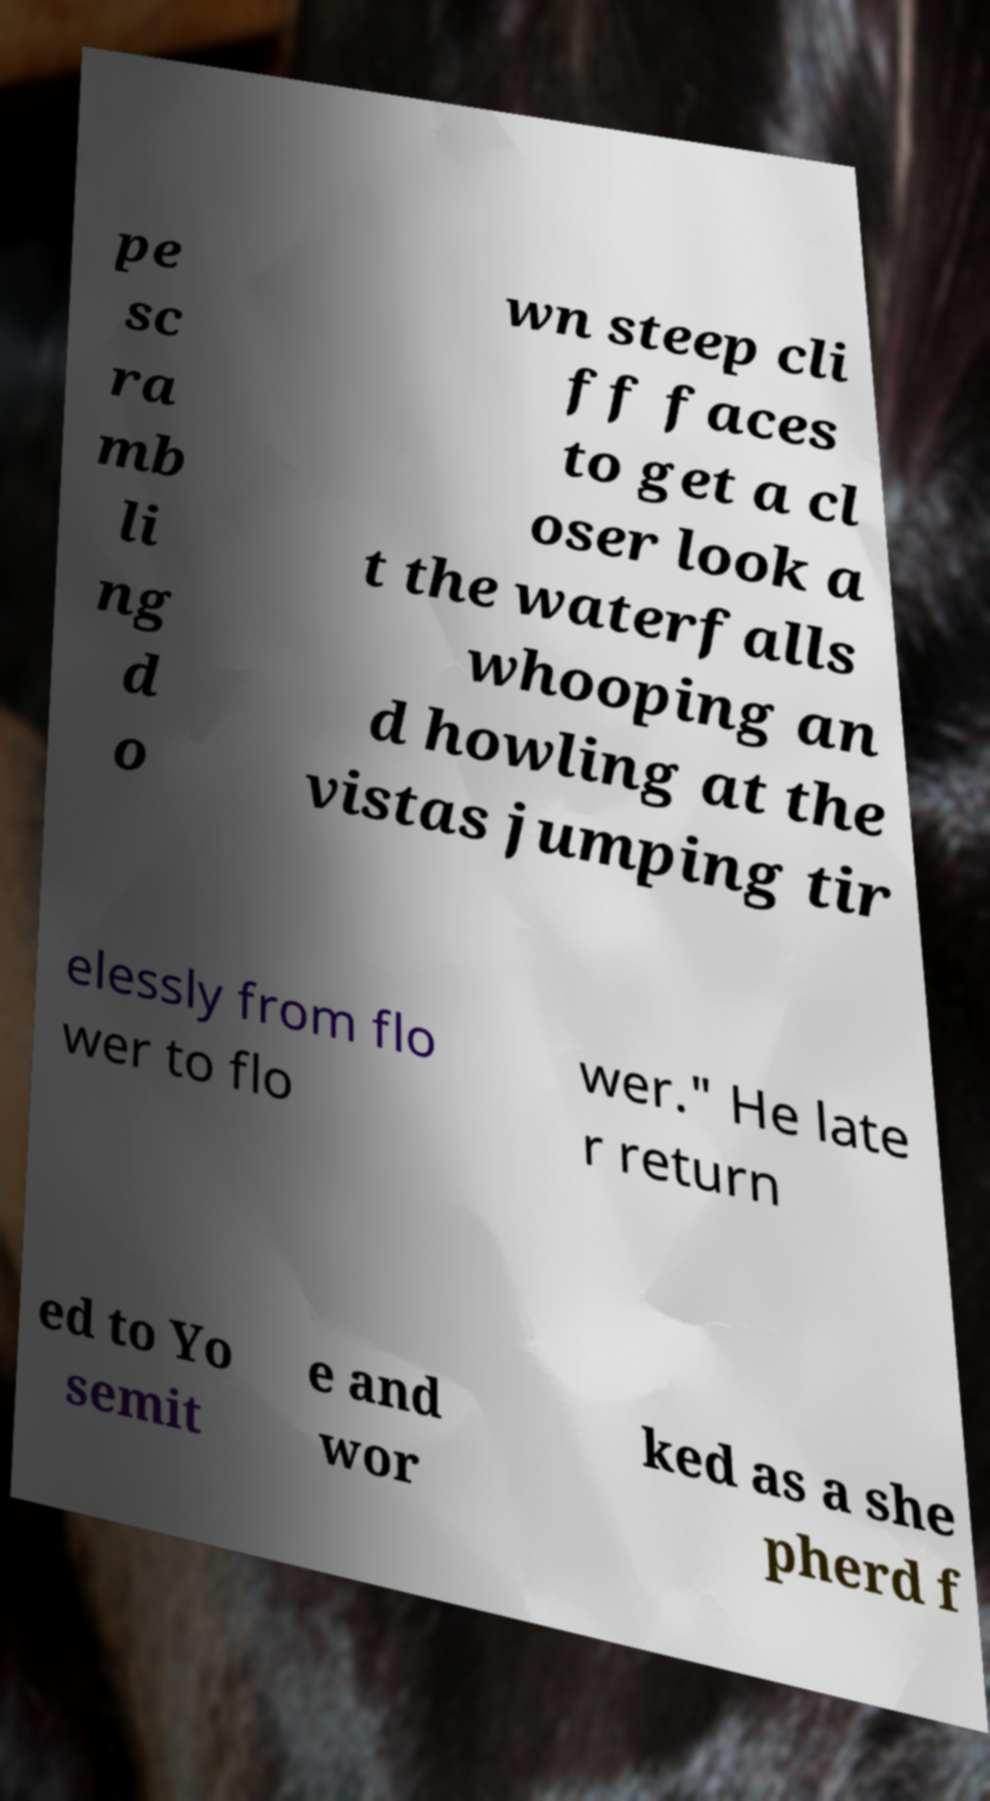Please read and relay the text visible in this image. What does it say? pe sc ra mb li ng d o wn steep cli ff faces to get a cl oser look a t the waterfalls whooping an d howling at the vistas jumping tir elessly from flo wer to flo wer." He late r return ed to Yo semit e and wor ked as a she pherd f 